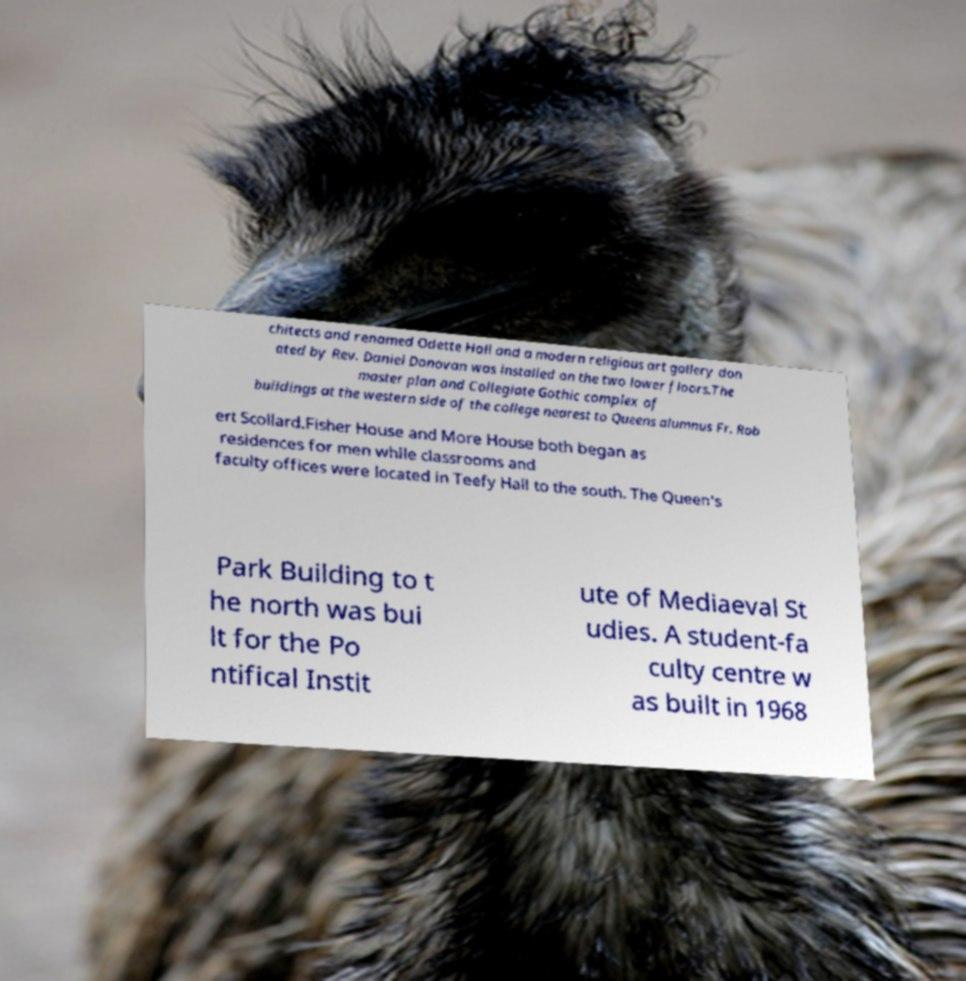Could you extract and type out the text from this image? chitects and renamed Odette Hall and a modern religious art gallery don ated by Rev. Daniel Donovan was installed on the two lower floors.The master plan and Collegiate Gothic complex of buildings at the western side of the college nearest to Queens alumnus Fr. Rob ert Scollard.Fisher House and More House both began as residences for men while classrooms and faculty offices were located in Teefy Hall to the south. The Queen's Park Building to t he north was bui lt for the Po ntifical Instit ute of Mediaeval St udies. A student-fa culty centre w as built in 1968 